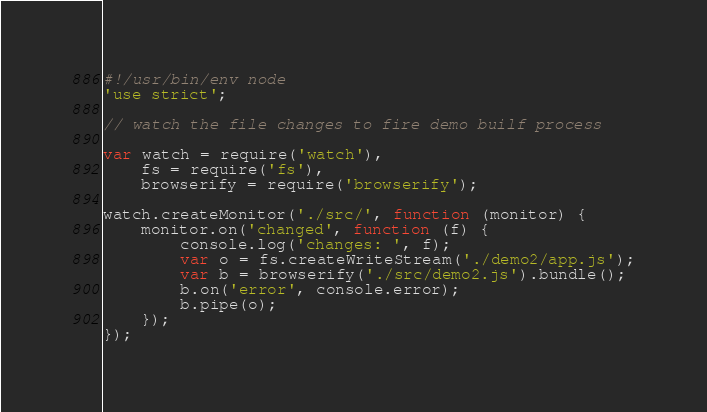<code> <loc_0><loc_0><loc_500><loc_500><_JavaScript_>#!/usr/bin/env node
'use strict';

// watch the file changes to fire demo builf process

var watch = require('watch'),
    fs = require('fs'),
    browserify = require('browserify');

watch.createMonitor('./src/', function (monitor) {
    monitor.on('changed', function (f) {
        console.log('changes: ', f);
        var o = fs.createWriteStream('./demo2/app.js');
        var b = browserify('./src/demo2.js').bundle();
        b.on('error', console.error);
        b.pipe(o);
    });
});
</code> 